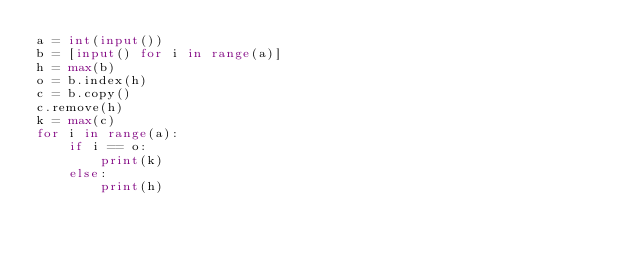<code> <loc_0><loc_0><loc_500><loc_500><_Python_>a = int(input())
b = [input() for i in range(a)]
h = max(b)
o = b.index(h)
c = b.copy()
c.remove(h)
k = max(c)
for i in range(a):
    if i == o:
        print(k)
    else:
        print(h)</code> 